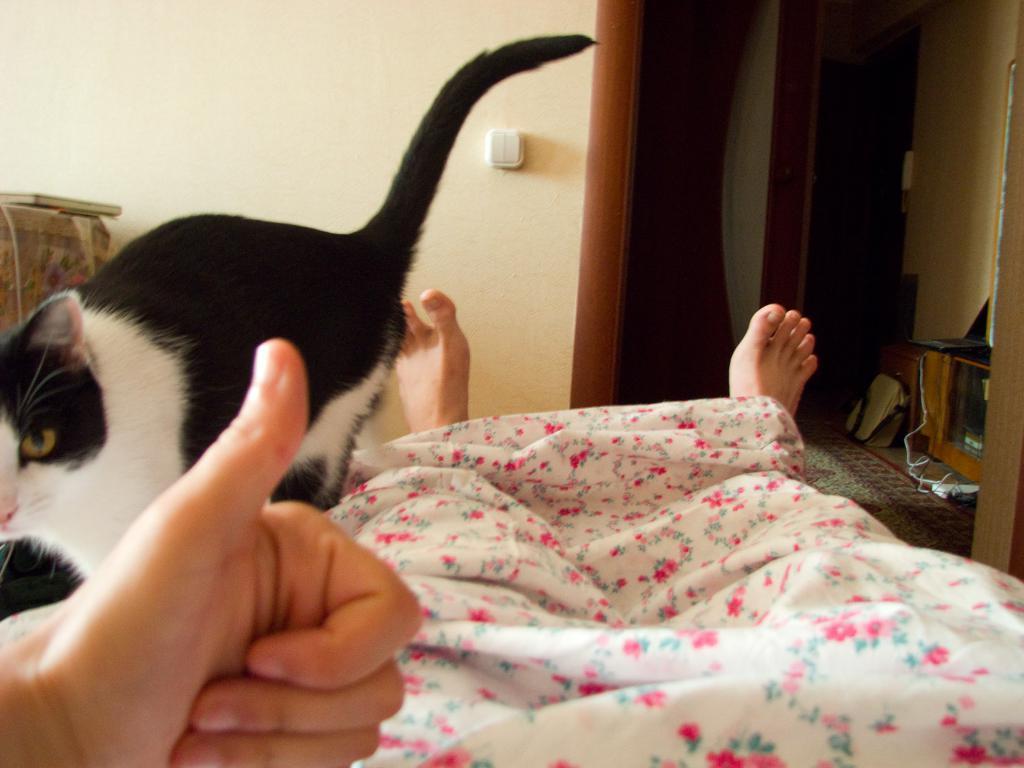Describe this image in one or two sentences. This picture shows a human and we see a blanket and a cat. It is white and black in color and we see a bag on the floor. 